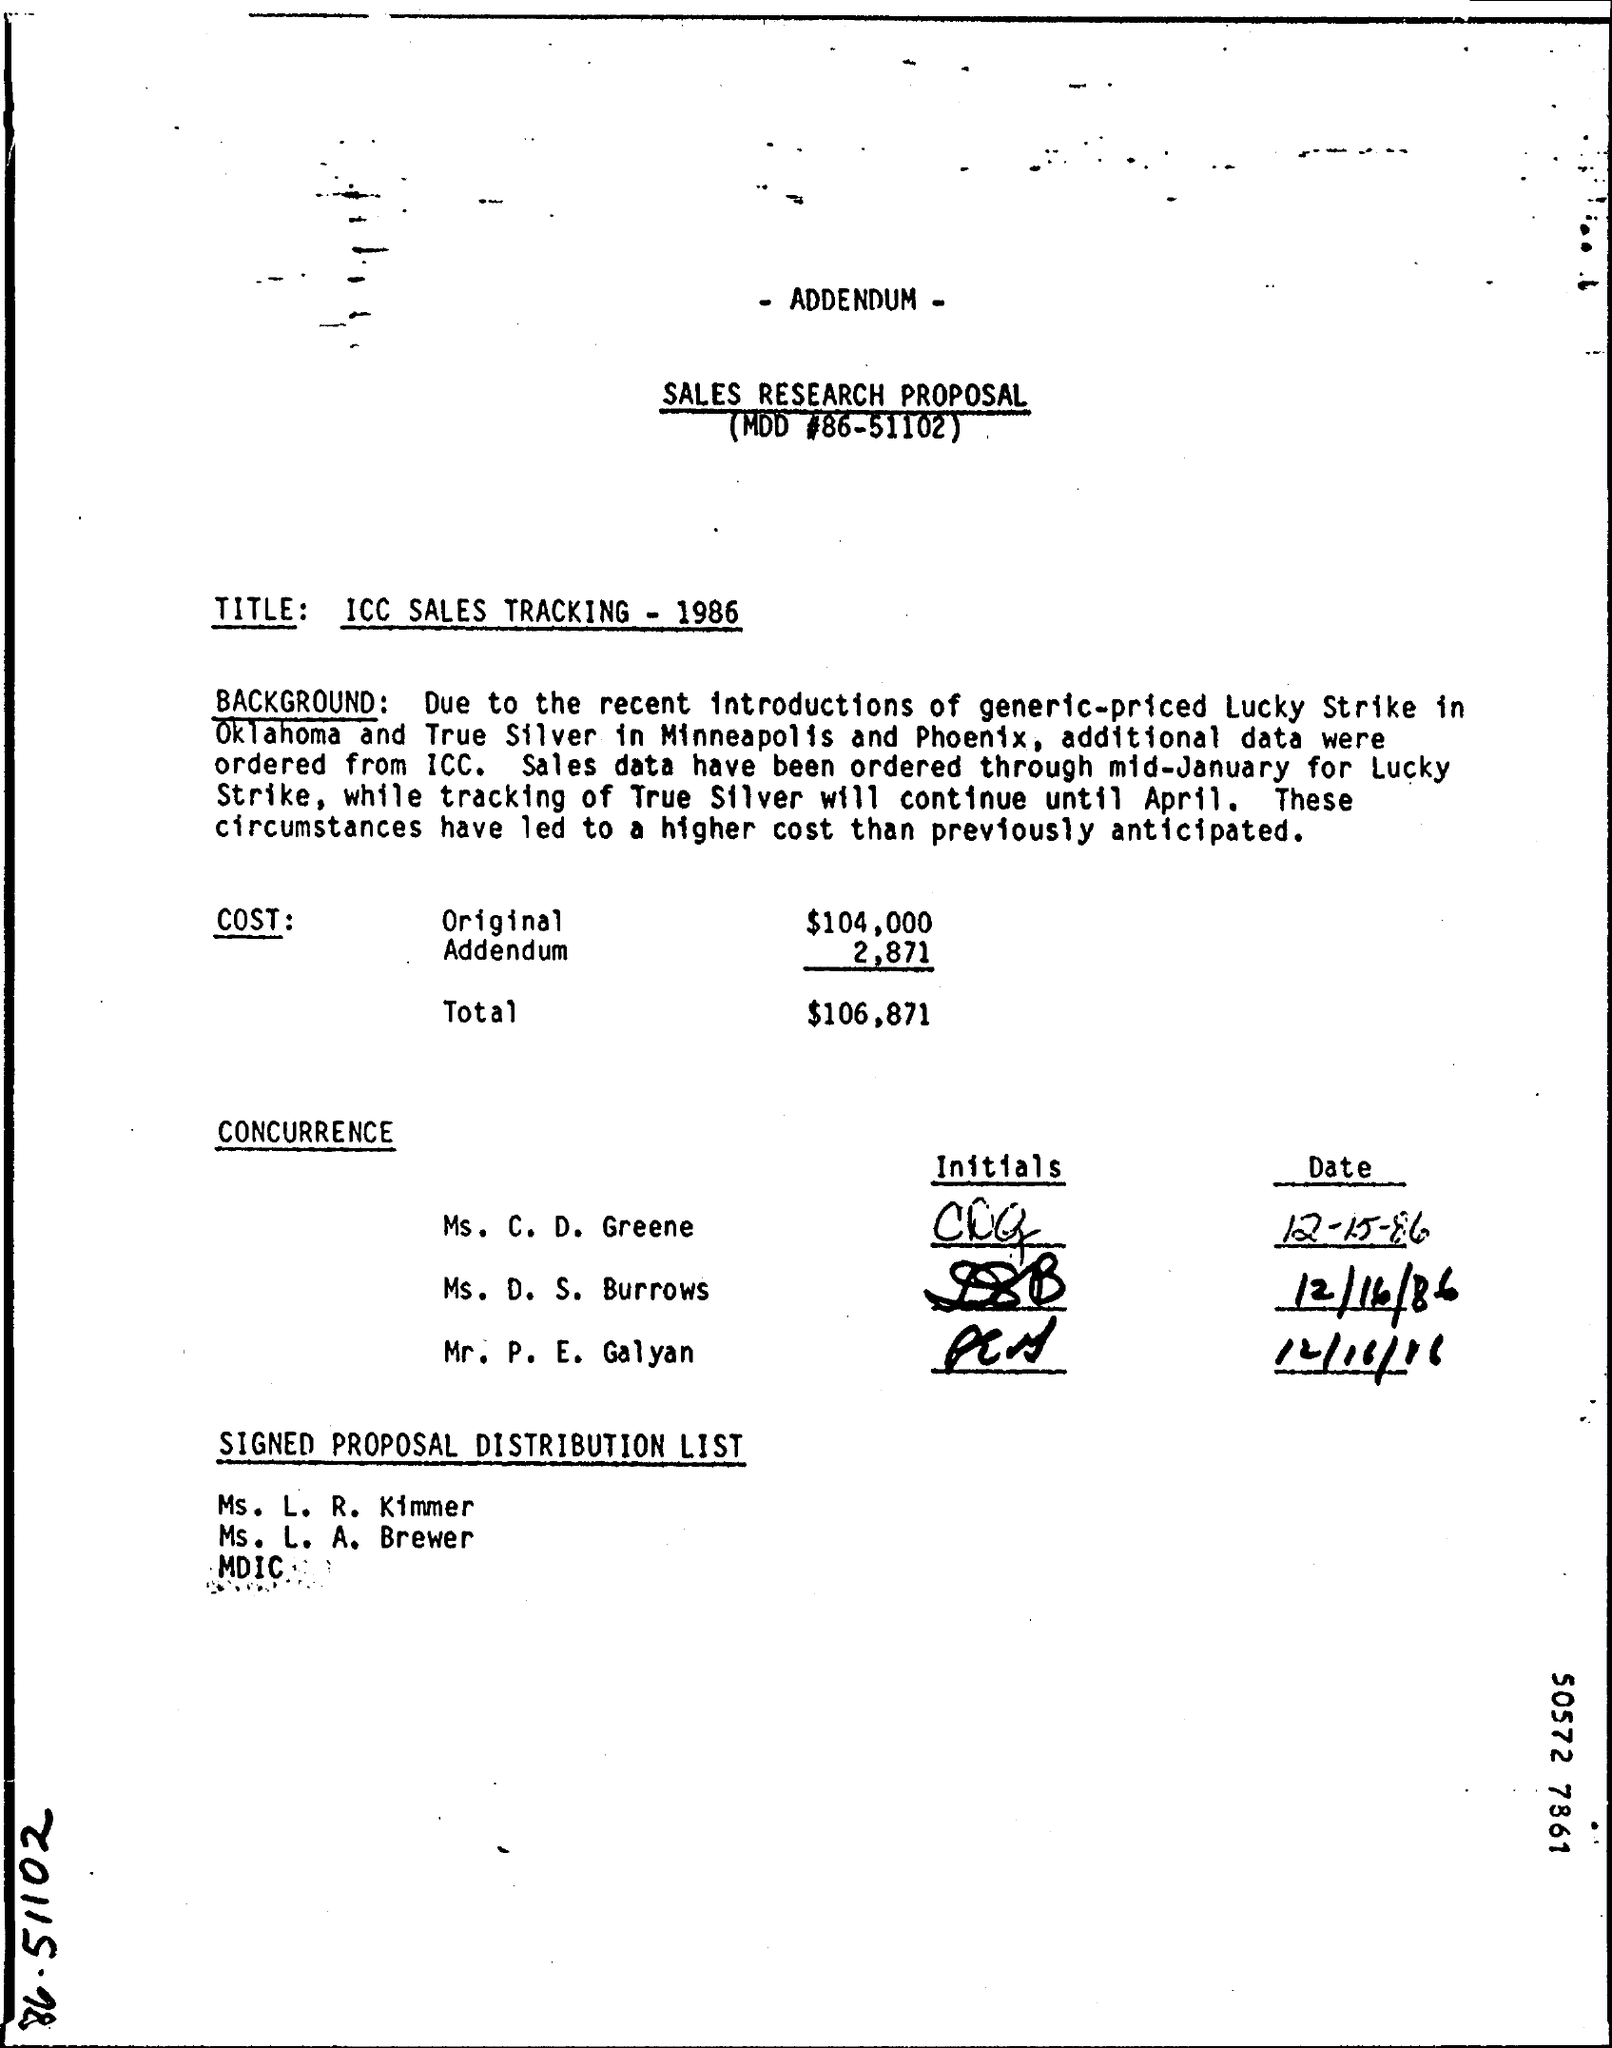Point out several critical features in this image. The original cost of $104,000 has been declared. The total cost is $106,871. The title of the Sales research proposal is 'ICC Sales Tracking - 1986'. The tracking of True Silver will continue until April. Lucky Strike is introduced in Oklahoma. 